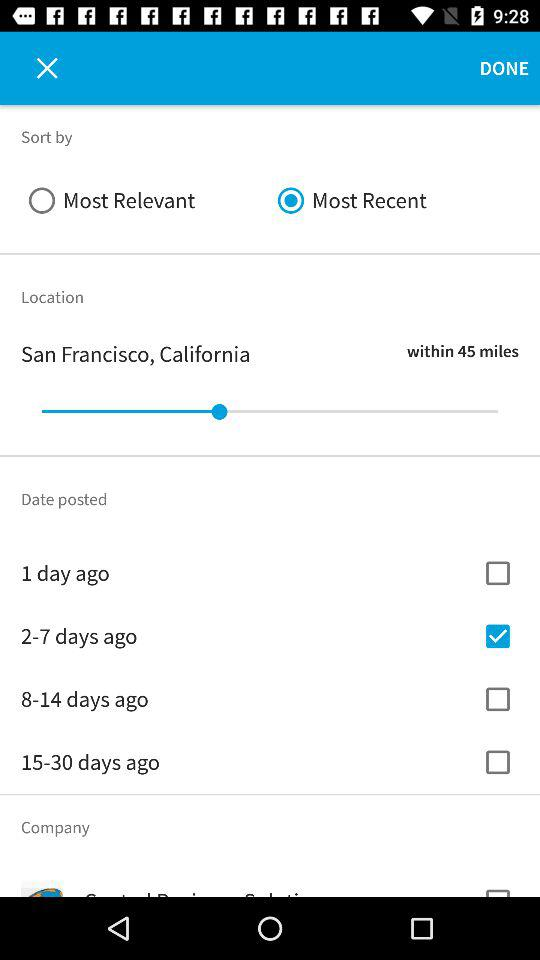What is the location? The location is San Francisco, California. 